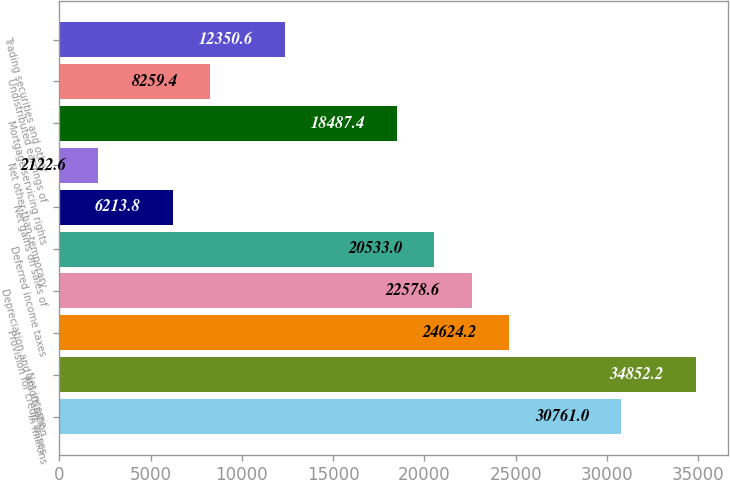Convert chart. <chart><loc_0><loc_0><loc_500><loc_500><bar_chart><fcel>In millions<fcel>Net income<fcel>Provision for credit losses<fcel>Depreciation and amortization<fcel>Deferred income taxes<fcel>Net gains on sales of<fcel>Net other-than-temporary<fcel>Mortgage servicing rights<fcel>Undistributed earnings of<fcel>Trading securities and other<nl><fcel>30761<fcel>34852.2<fcel>24624.2<fcel>22578.6<fcel>20533<fcel>6213.8<fcel>2122.6<fcel>18487.4<fcel>8259.4<fcel>12350.6<nl></chart> 